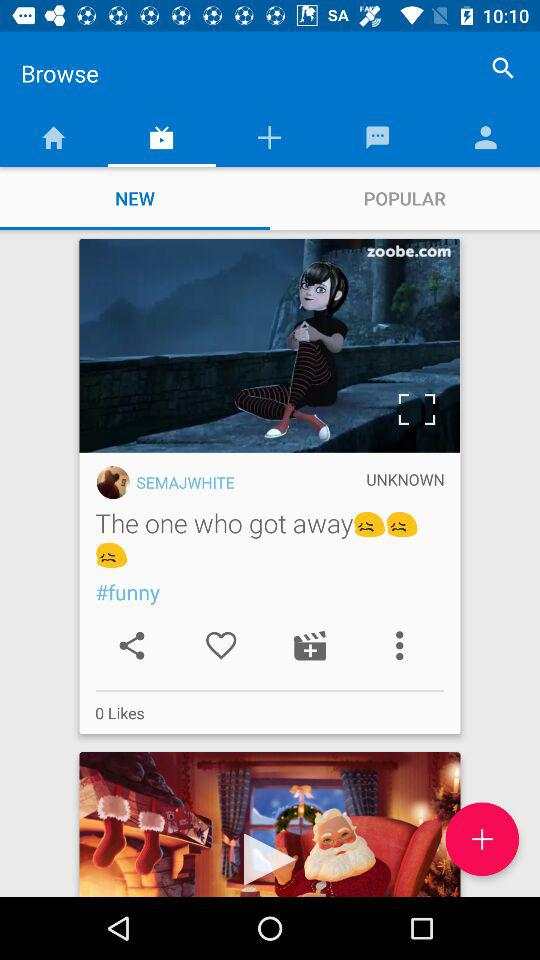How many more sad faces are there than likes?
Answer the question using a single word or phrase. 3 